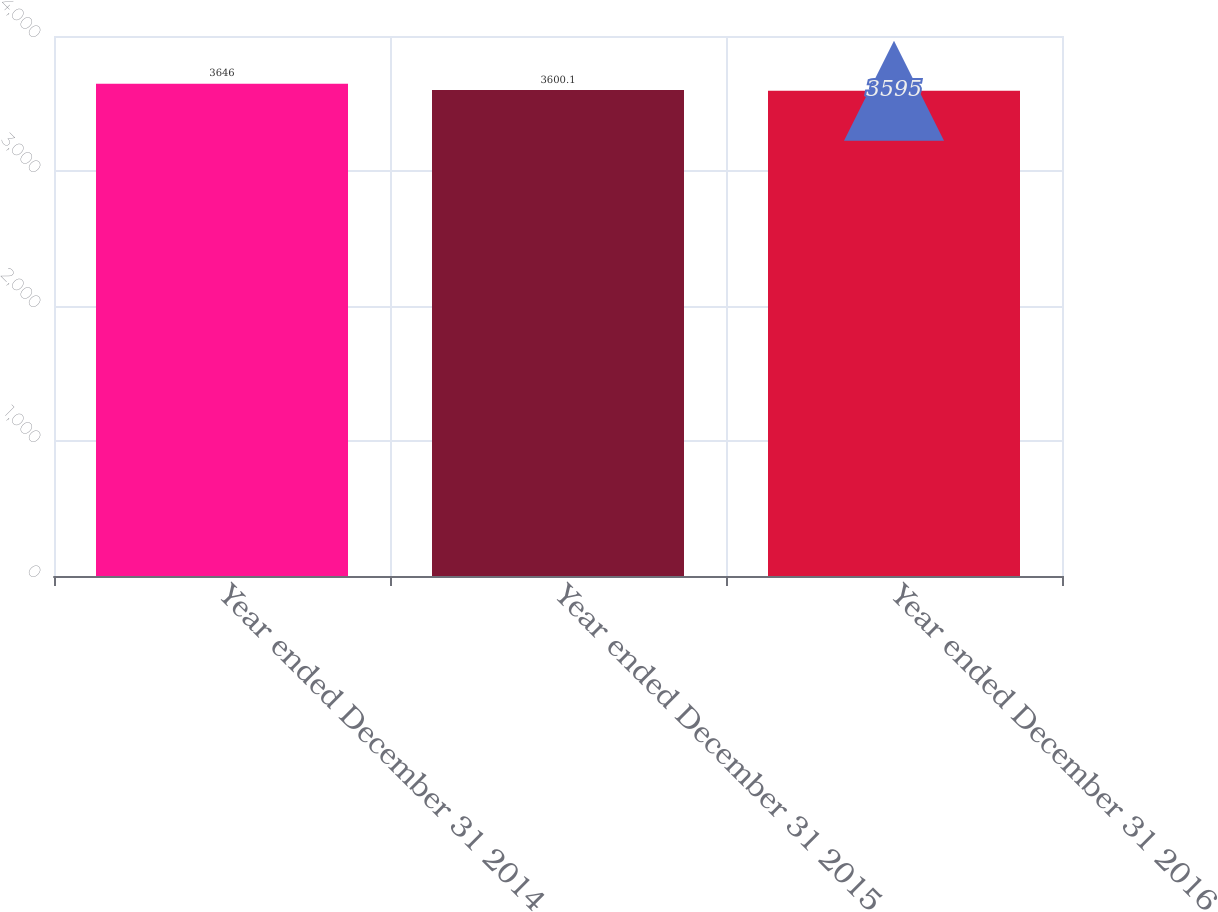Convert chart. <chart><loc_0><loc_0><loc_500><loc_500><bar_chart><fcel>Year ended December 31 2014<fcel>Year ended December 31 2015<fcel>Year ended December 31 2016<nl><fcel>3646<fcel>3600.1<fcel>3595<nl></chart> 